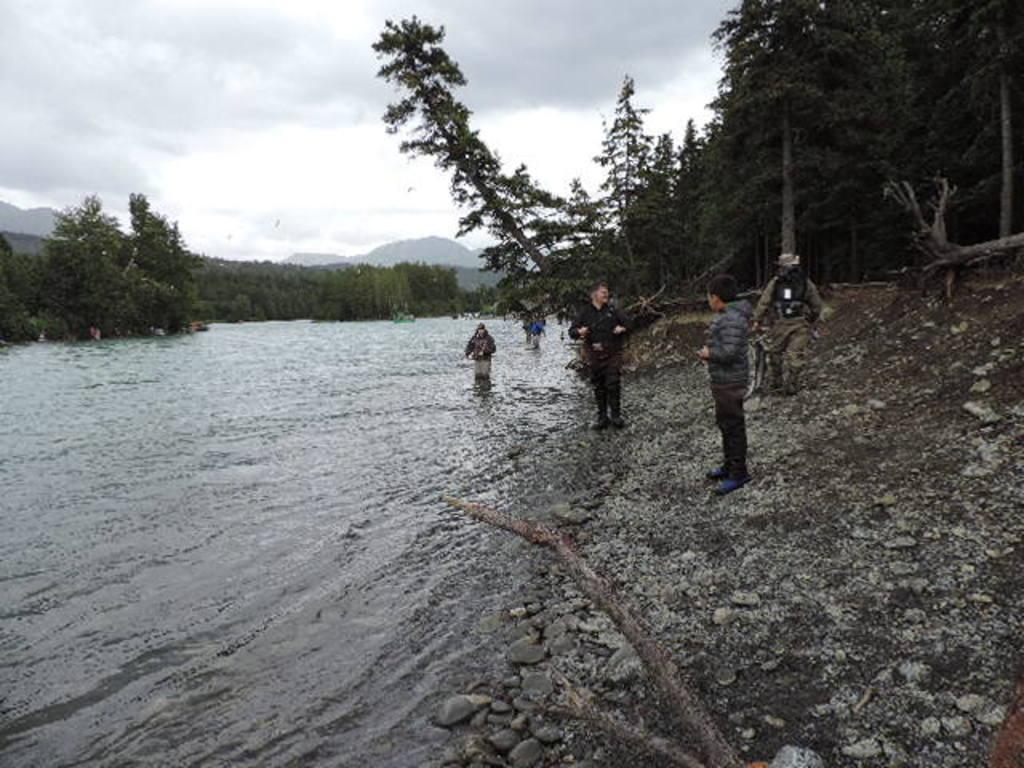Please provide a concise description of this image. In this image we can see a few people, among them, some people are in the water and some people are standing on the ground, there are some stones, trees and mountains, also we can see the sky with clouds. 